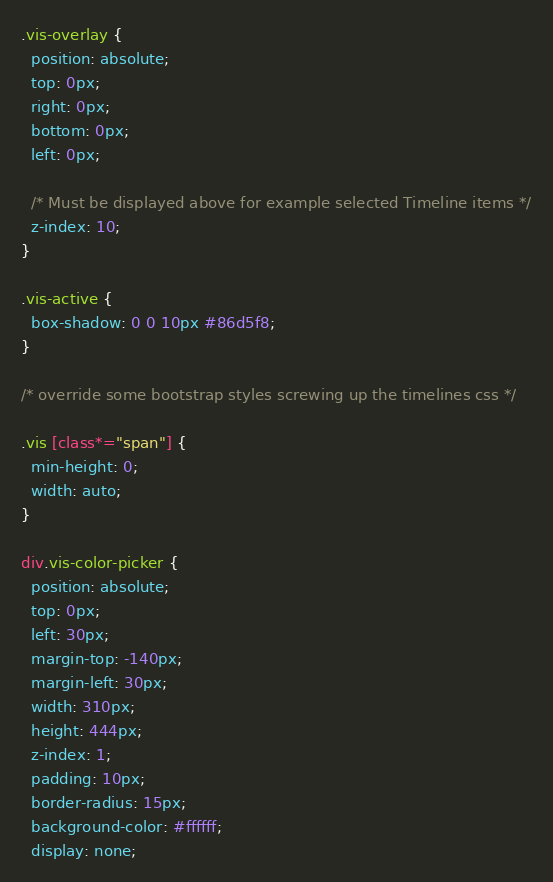<code> <loc_0><loc_0><loc_500><loc_500><_CSS_>.vis-overlay {
  position: absolute;
  top: 0px;
  right: 0px;
  bottom: 0px;
  left: 0px;

  /* Must be displayed above for example selected Timeline items */
  z-index: 10;
}

.vis-active {
  box-shadow: 0 0 10px #86d5f8;
}

/* override some bootstrap styles screwing up the timelines css */

.vis [class*="span"] {
  min-height: 0;
  width: auto;
}

div.vis-color-picker {
  position: absolute;
  top: 0px;
  left: 30px;
  margin-top: -140px;
  margin-left: 30px;
  width: 310px;
  height: 444px;
  z-index: 1;
  padding: 10px;
  border-radius: 15px;
  background-color: #ffffff;
  display: none;</code> 